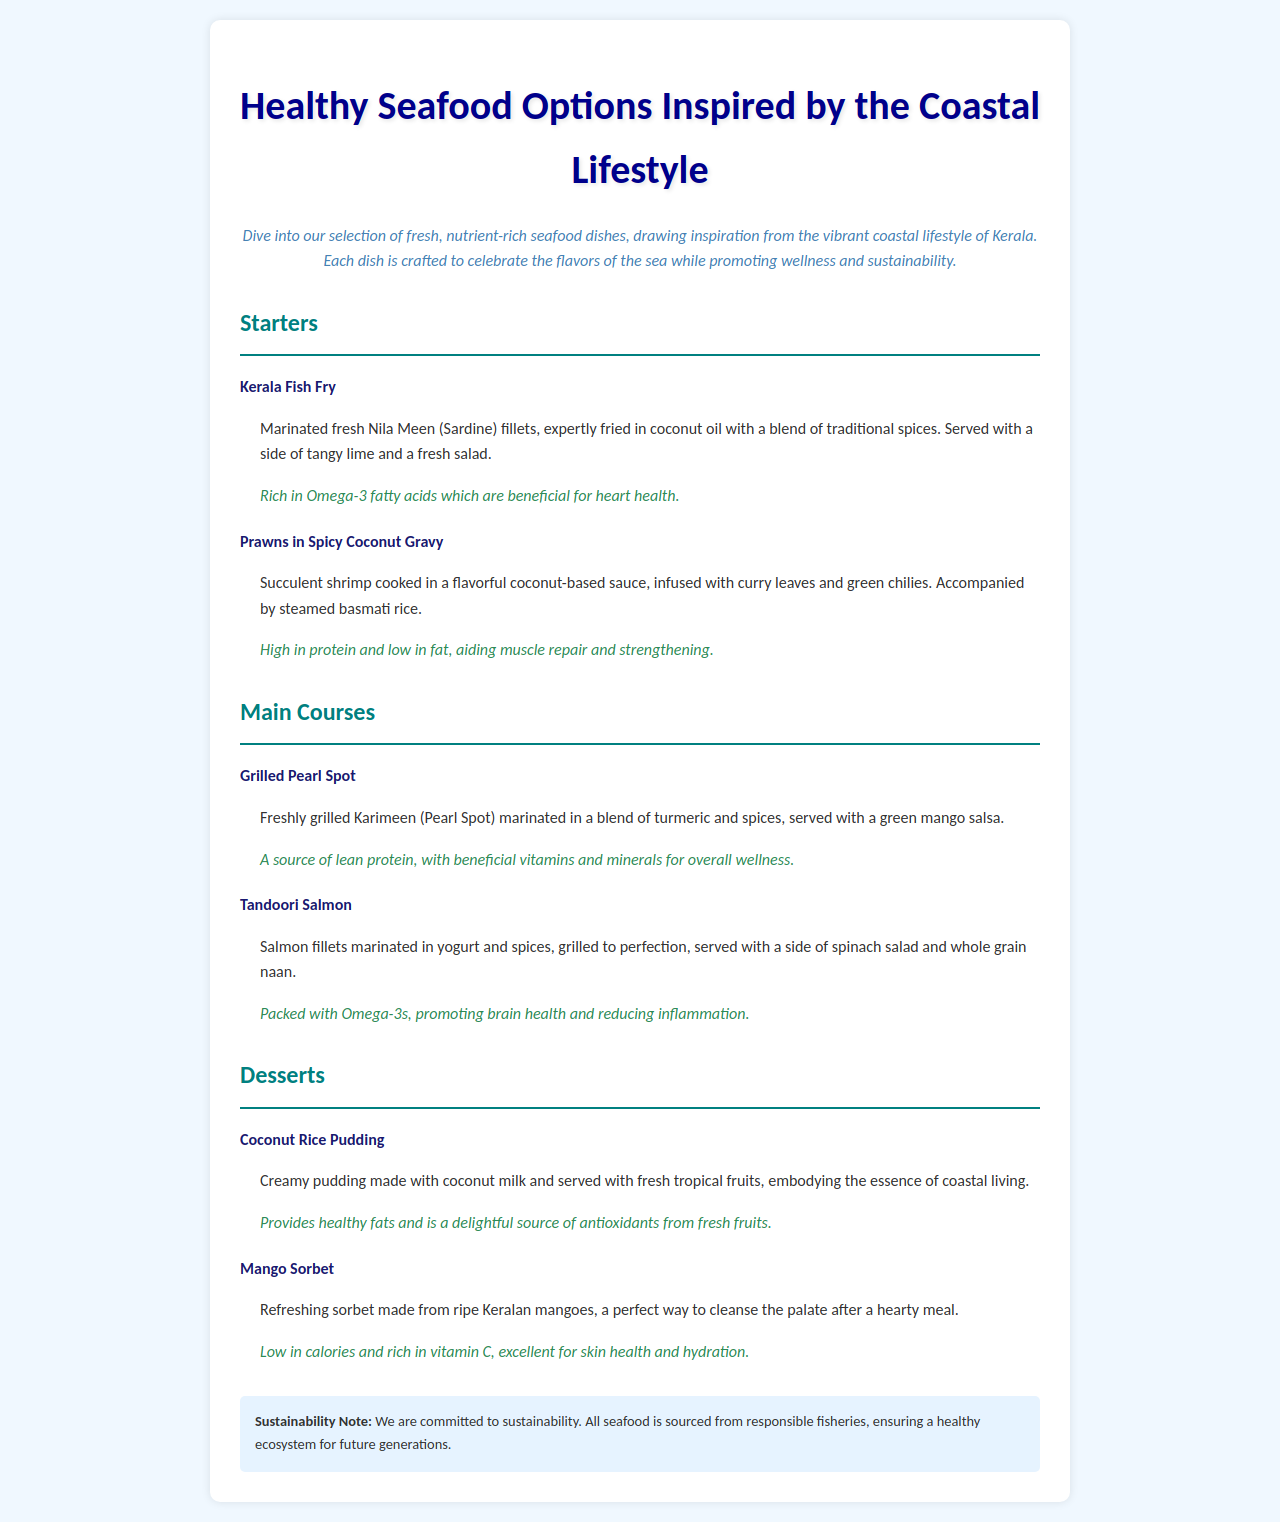What is the title of the menu? The title of the menu is presented prominently at the top of the document.
Answer: Healthy Seafood Options Inspired by the Coastal Lifestyle What dish is served with a side of tangy lime? The dish that includes a side of tangy lime is clearly stated in its description.
Answer: Kerala Fish Fry What type of fish is used in the Grilled Pearl Spot dish? The specific type of fish is mentioned in the dish description.
Answer: Karimeen Which dessert is low in calories and rich in vitamin C? The dessert description includes health-related information about its nutritional content.
Answer: Mango Sorbet What cooking method is used for the Tandoori Salmon? The preparation method is explicitly mentioned in the dish description.
Answer: Grilled How many starters are listed on the menu? The number of starters can be counted from the section in the document.
Answer: 2 What key nutritional benefit is highlighted for Prawns in Spicy Coconut Gravy? The health benefits associated with the dish are stated in the description.
Answer: High in protein and low in fat What type of oil is used for frying the Kerala Fish Fry? The type of oil used is specified in the dish description for clarity.
Answer: Coconut oil What is the sustainability note about? The sustainability note outlines the restaurant's commitment to sourcing seafood.
Answer: Sustainability in seafood sourcing 